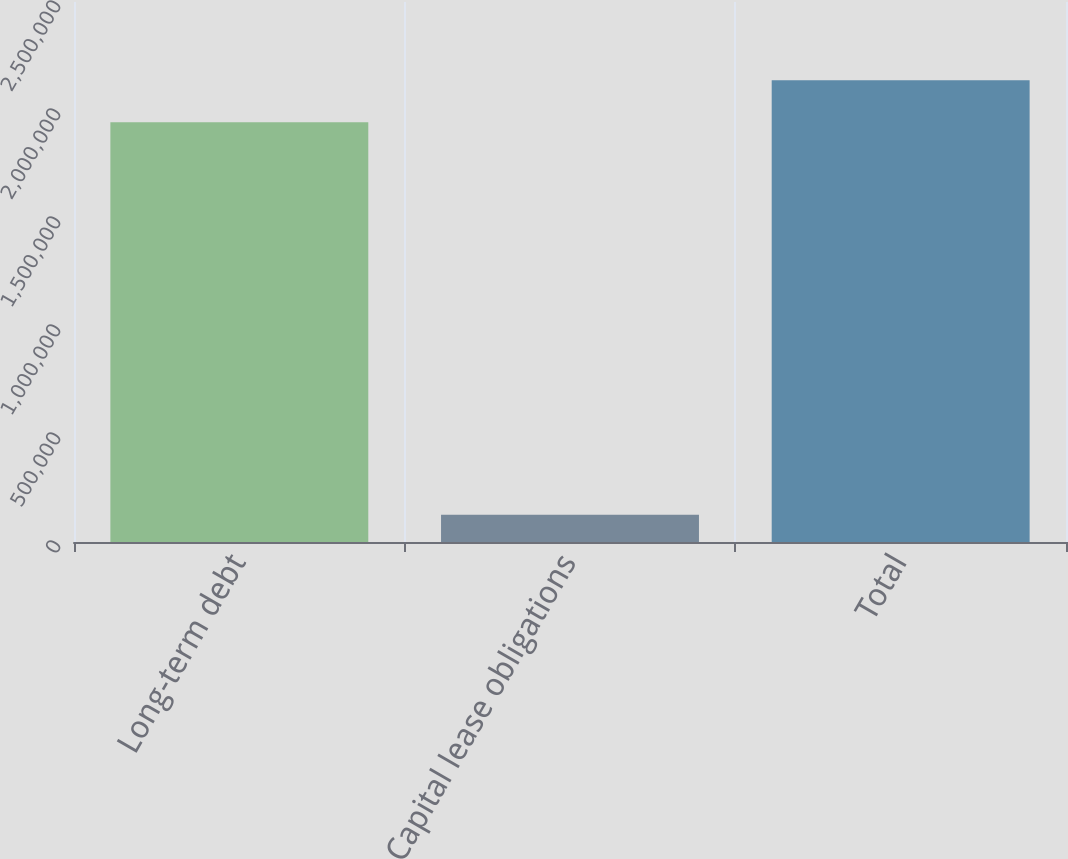<chart> <loc_0><loc_0><loc_500><loc_500><bar_chart><fcel>Long-term debt<fcel>Capital lease obligations<fcel>Total<nl><fcel>1.94379e+06<fcel>126541<fcel>2.13816e+06<nl></chart> 